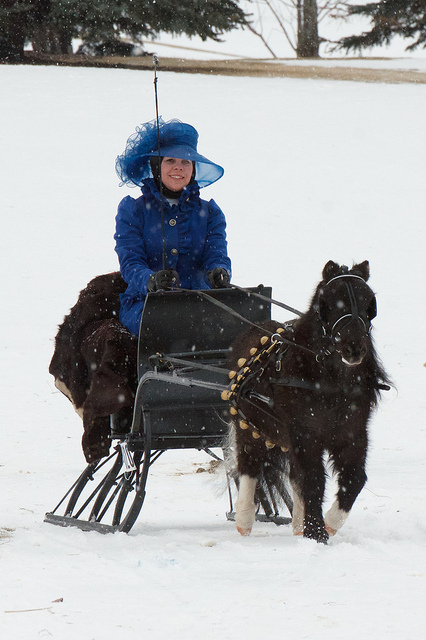What is the person wearing in this winter setting? The person is clad in a vibrant blue coat and hat, which creates a lovely contrast with the white snowy background. 